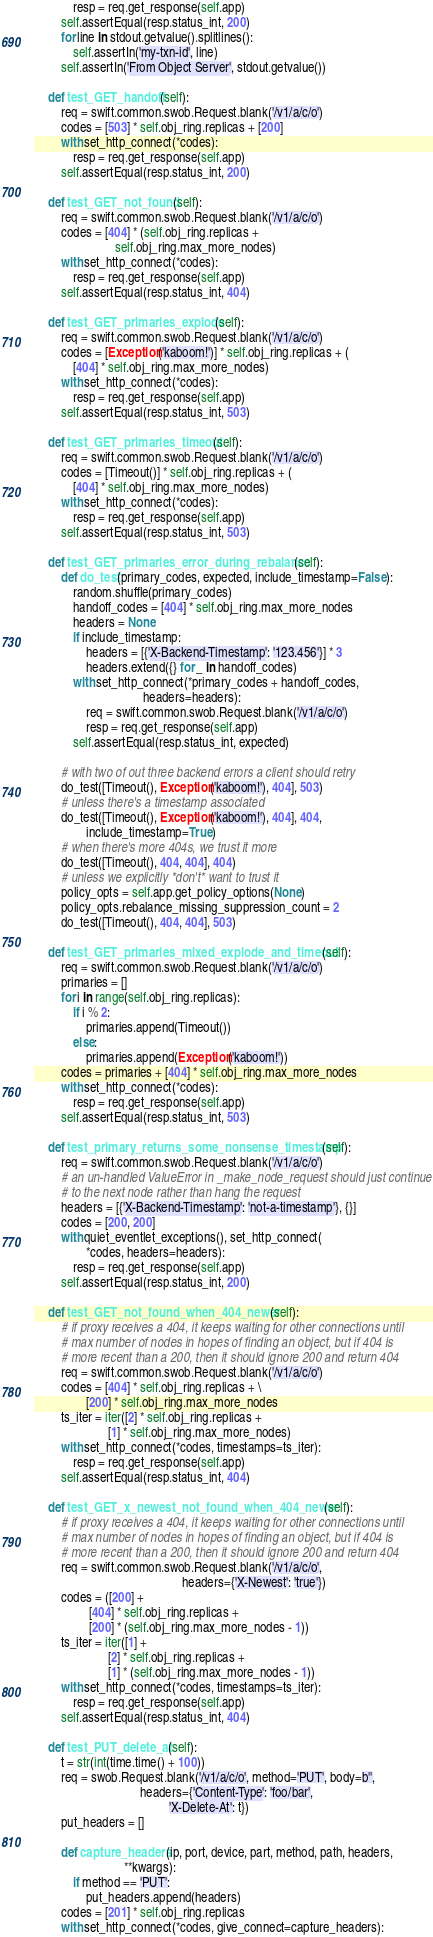Convert code to text. <code><loc_0><loc_0><loc_500><loc_500><_Python_>            resp = req.get_response(self.app)
        self.assertEqual(resp.status_int, 200)
        for line in stdout.getvalue().splitlines():
            self.assertIn('my-txn-id', line)
        self.assertIn('From Object Server', stdout.getvalue())

    def test_GET_handoff(self):
        req = swift.common.swob.Request.blank('/v1/a/c/o')
        codes = [503] * self.obj_ring.replicas + [200]
        with set_http_connect(*codes):
            resp = req.get_response(self.app)
        self.assertEqual(resp.status_int, 200)

    def test_GET_not_found(self):
        req = swift.common.swob.Request.blank('/v1/a/c/o')
        codes = [404] * (self.obj_ring.replicas +
                         self.obj_ring.max_more_nodes)
        with set_http_connect(*codes):
            resp = req.get_response(self.app)
        self.assertEqual(resp.status_int, 404)

    def test_GET_primaries_explode(self):
        req = swift.common.swob.Request.blank('/v1/a/c/o')
        codes = [Exception('kaboom!')] * self.obj_ring.replicas + (
            [404] * self.obj_ring.max_more_nodes)
        with set_http_connect(*codes):
            resp = req.get_response(self.app)
        self.assertEqual(resp.status_int, 503)

    def test_GET_primaries_timeout(self):
        req = swift.common.swob.Request.blank('/v1/a/c/o')
        codes = [Timeout()] * self.obj_ring.replicas + (
            [404] * self.obj_ring.max_more_nodes)
        with set_http_connect(*codes):
            resp = req.get_response(self.app)
        self.assertEqual(resp.status_int, 503)

    def test_GET_primaries_error_during_rebalance(self):
        def do_test(primary_codes, expected, include_timestamp=False):
            random.shuffle(primary_codes)
            handoff_codes = [404] * self.obj_ring.max_more_nodes
            headers = None
            if include_timestamp:
                headers = [{'X-Backend-Timestamp': '123.456'}] * 3
                headers.extend({} for _ in handoff_codes)
            with set_http_connect(*primary_codes + handoff_codes,
                                  headers=headers):
                req = swift.common.swob.Request.blank('/v1/a/c/o')
                resp = req.get_response(self.app)
            self.assertEqual(resp.status_int, expected)

        # with two of out three backend errors a client should retry
        do_test([Timeout(), Exception('kaboom!'), 404], 503)
        # unless there's a timestamp associated
        do_test([Timeout(), Exception('kaboom!'), 404], 404,
                include_timestamp=True)
        # when there's more 404s, we trust it more
        do_test([Timeout(), 404, 404], 404)
        # unless we explicitly *don't* want to trust it
        policy_opts = self.app.get_policy_options(None)
        policy_opts.rebalance_missing_suppression_count = 2
        do_test([Timeout(), 404, 404], 503)

    def test_GET_primaries_mixed_explode_and_timeout(self):
        req = swift.common.swob.Request.blank('/v1/a/c/o')
        primaries = []
        for i in range(self.obj_ring.replicas):
            if i % 2:
                primaries.append(Timeout())
            else:
                primaries.append(Exception('kaboom!'))
        codes = primaries + [404] * self.obj_ring.max_more_nodes
        with set_http_connect(*codes):
            resp = req.get_response(self.app)
        self.assertEqual(resp.status_int, 503)

    def test_primary_returns_some_nonsense_timestamp(self):
        req = swift.common.swob.Request.blank('/v1/a/c/o')
        # an un-handled ValueError in _make_node_request should just continue
        # to the next node rather than hang the request
        headers = [{'X-Backend-Timestamp': 'not-a-timestamp'}, {}]
        codes = [200, 200]
        with quiet_eventlet_exceptions(), set_http_connect(
                *codes, headers=headers):
            resp = req.get_response(self.app)
        self.assertEqual(resp.status_int, 200)

    def test_GET_not_found_when_404_newer(self):
        # if proxy receives a 404, it keeps waiting for other connections until
        # max number of nodes in hopes of finding an object, but if 404 is
        # more recent than a 200, then it should ignore 200 and return 404
        req = swift.common.swob.Request.blank('/v1/a/c/o')
        codes = [404] * self.obj_ring.replicas + \
                [200] * self.obj_ring.max_more_nodes
        ts_iter = iter([2] * self.obj_ring.replicas +
                       [1] * self.obj_ring.max_more_nodes)
        with set_http_connect(*codes, timestamps=ts_iter):
            resp = req.get_response(self.app)
        self.assertEqual(resp.status_int, 404)

    def test_GET_x_newest_not_found_when_404_newer(self):
        # if proxy receives a 404, it keeps waiting for other connections until
        # max number of nodes in hopes of finding an object, but if 404 is
        # more recent than a 200, then it should ignore 200 and return 404
        req = swift.common.swob.Request.blank('/v1/a/c/o',
                                              headers={'X-Newest': 'true'})
        codes = ([200] +
                 [404] * self.obj_ring.replicas +
                 [200] * (self.obj_ring.max_more_nodes - 1))
        ts_iter = iter([1] +
                       [2] * self.obj_ring.replicas +
                       [1] * (self.obj_ring.max_more_nodes - 1))
        with set_http_connect(*codes, timestamps=ts_iter):
            resp = req.get_response(self.app)
        self.assertEqual(resp.status_int, 404)

    def test_PUT_delete_at(self):
        t = str(int(time.time() + 100))
        req = swob.Request.blank('/v1/a/c/o', method='PUT', body=b'',
                                 headers={'Content-Type': 'foo/bar',
                                          'X-Delete-At': t})
        put_headers = []

        def capture_headers(ip, port, device, part, method, path, headers,
                            **kwargs):
            if method == 'PUT':
                put_headers.append(headers)
        codes = [201] * self.obj_ring.replicas
        with set_http_connect(*codes, give_connect=capture_headers):</code> 